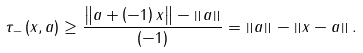Convert formula to latex. <formula><loc_0><loc_0><loc_500><loc_500>\tau _ { - } \left ( x , a \right ) \geq \frac { \left \| a + \left ( - 1 \right ) x \right \| - \left \| a \right \| } { \left ( - 1 \right ) } = \left \| a \right \| - \left \| x - a \right \| .</formula> 